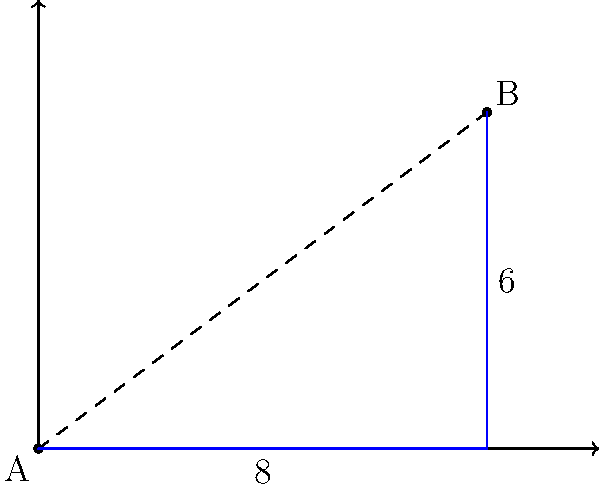As a delivery driver for your part-time job, you need to plan the most efficient route between two locations. On the city map, point A represents your current location, and point B is the delivery destination. If each unit on the map represents 1 kilometer, what is the shortest distance between points A and B? To find the shortest distance between two points on a coordinate plane, we can use the distance formula, which is derived from the Pythagorean theorem.

Step 1: Identify the coordinates of the two points.
Point A: (0, 0)
Point B: (8, 6)

Step 2: Apply the distance formula:
$$d = \sqrt{(x_2 - x_1)^2 + (y_2 - y_1)^2}$$

Step 3: Plug in the values:
$$d = \sqrt{(8 - 0)^2 + (6 - 0)^2}$$

Step 4: Simplify:
$$d = \sqrt{8^2 + 6^2}$$
$$d = \sqrt{64 + 36}$$
$$d = \sqrt{100}$$

Step 5: Calculate the final result:
$$d = 10$$

Therefore, the shortest distance between points A and B is 10 kilometers.
Answer: 10 km 